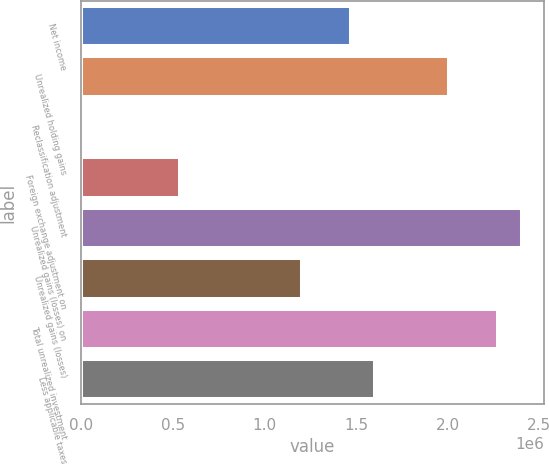<chart> <loc_0><loc_0><loc_500><loc_500><bar_chart><fcel>Net income<fcel>Unrealized holding gains<fcel>Reclassification adjustment<fcel>Foreign exchange adjustment on<fcel>Unrealized gains (losses) on<fcel>Unrealized gains (losses)<fcel>Total unrealized investment<fcel>Less applicable taxes<nl><fcel>1.47265e+06<fcel>2.00591e+06<fcel>6183<fcel>539443<fcel>2.40585e+06<fcel>1.20602e+06<fcel>2.27254e+06<fcel>1.60596e+06<nl></chart> 